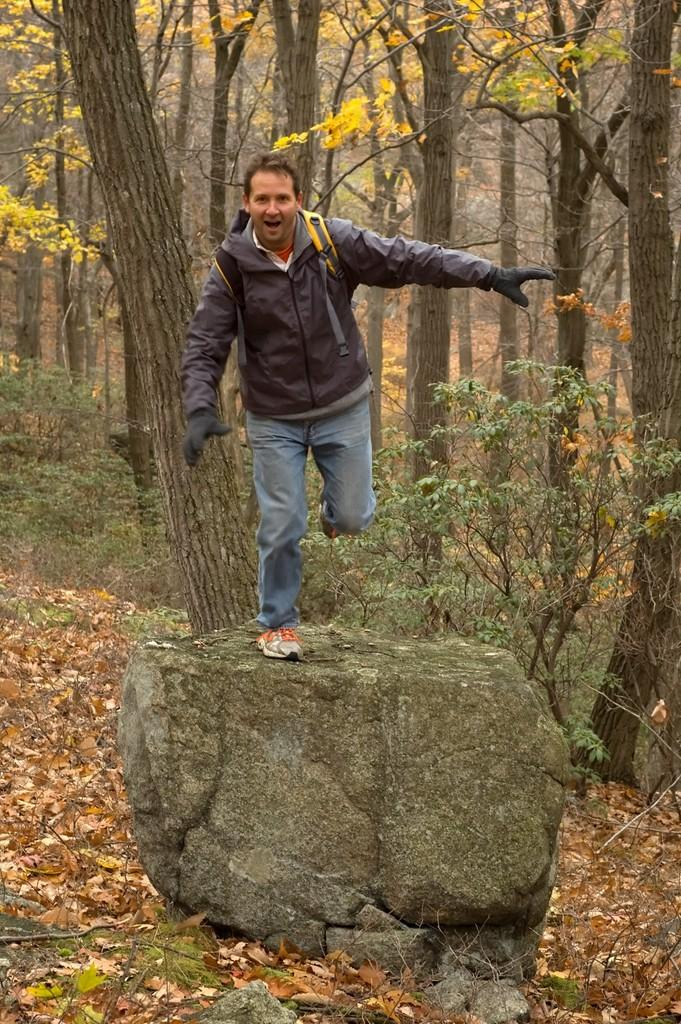What is the man in the image doing? The man in the image is in motion. What type of natural elements can be seen in the image? There are rocks, leaves, plants, and trees in the image. What is visible in the background of the image? In the background of the image, there are plants and trees. How many brothers can be seen in the image? There are no brothers present in the image; it only features a man in motion. What type of flesh is visible in the image? There is no flesh visible in the image; it primarily features natural elements such as rocks, leaves, plants, and trees. 